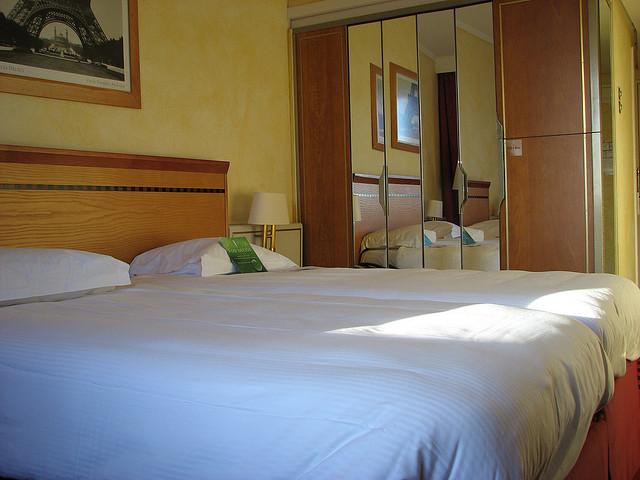What color is the pamphlet on the bed?
Quick response, please. Green. Are there any mirrors?
Give a very brief answer. Yes. Could this be a commercial room for rent?
Write a very short answer. Yes. Is this a black and white photo?
Write a very short answer. No. How many pillows are on the bed?
Give a very brief answer. 2. 